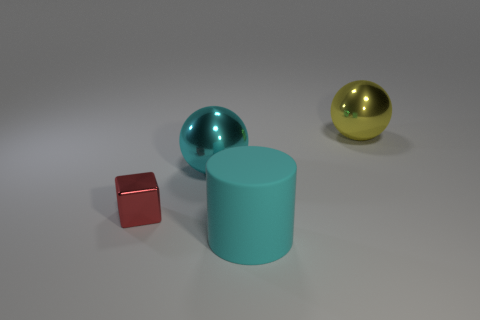There is a cyan object that is in front of the cube; does it have the same size as the small red metallic thing?
Offer a very short reply. No. Does the rubber cylinder have the same color as the cube?
Keep it short and to the point. No. What number of tiny cubes are there?
Make the answer very short. 1. What number of cylinders are either big rubber things or yellow things?
Keep it short and to the point. 1. What number of small red metallic blocks are behind the object left of the cyan shiny object?
Ensure brevity in your answer.  0. Is the large cyan ball made of the same material as the red cube?
Your answer should be compact. Yes. What size is the shiny sphere that is the same color as the rubber thing?
Make the answer very short. Large. Are there any other blocks made of the same material as the red block?
Provide a short and direct response. No. There is a object behind the metal sphere to the left of the large thing that is in front of the red shiny cube; what color is it?
Your answer should be compact. Yellow. How many cyan objects are either large cylinders or large balls?
Offer a terse response. 2. 